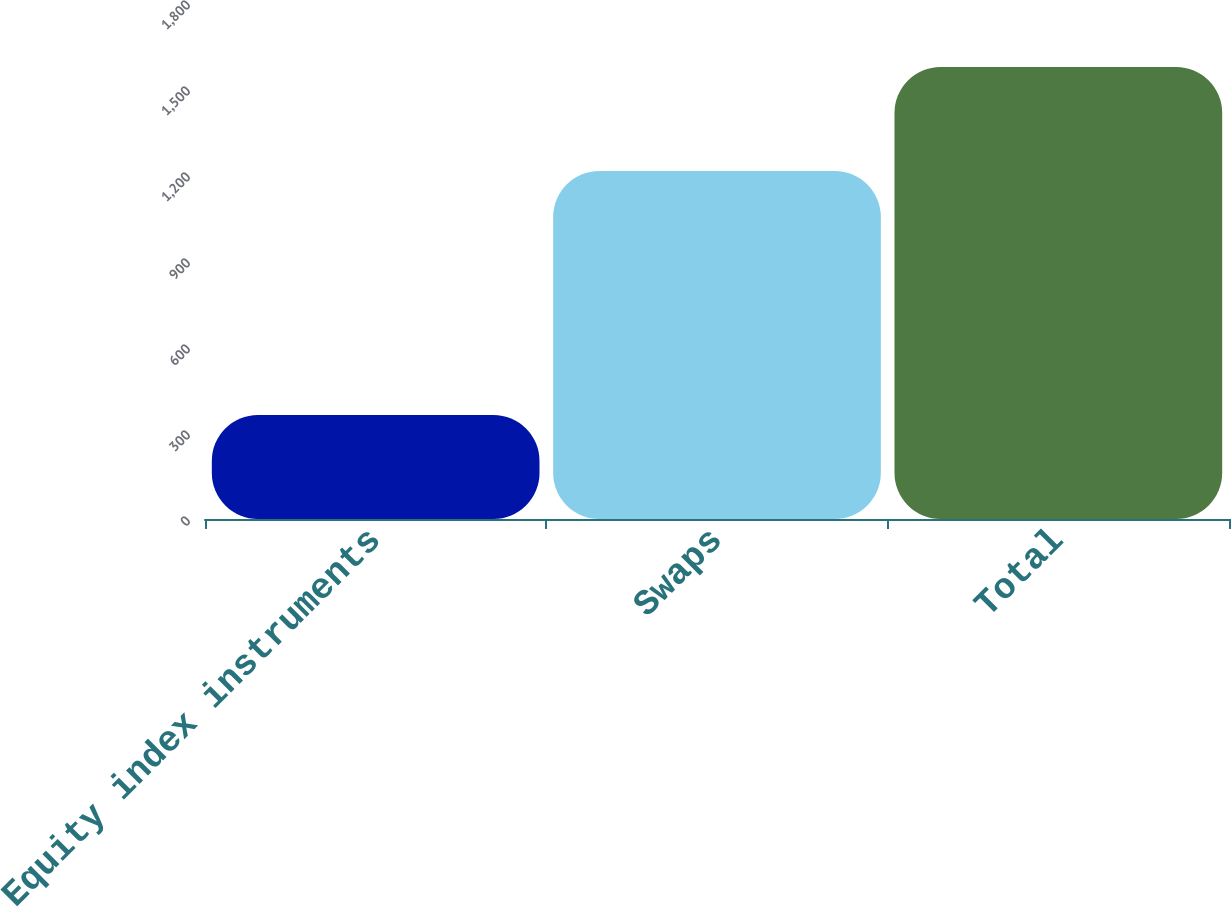Convert chart to OTSL. <chart><loc_0><loc_0><loc_500><loc_500><bar_chart><fcel>Equity index instruments<fcel>Swaps<fcel>Total<nl><fcel>363<fcel>1214<fcel>1577<nl></chart> 